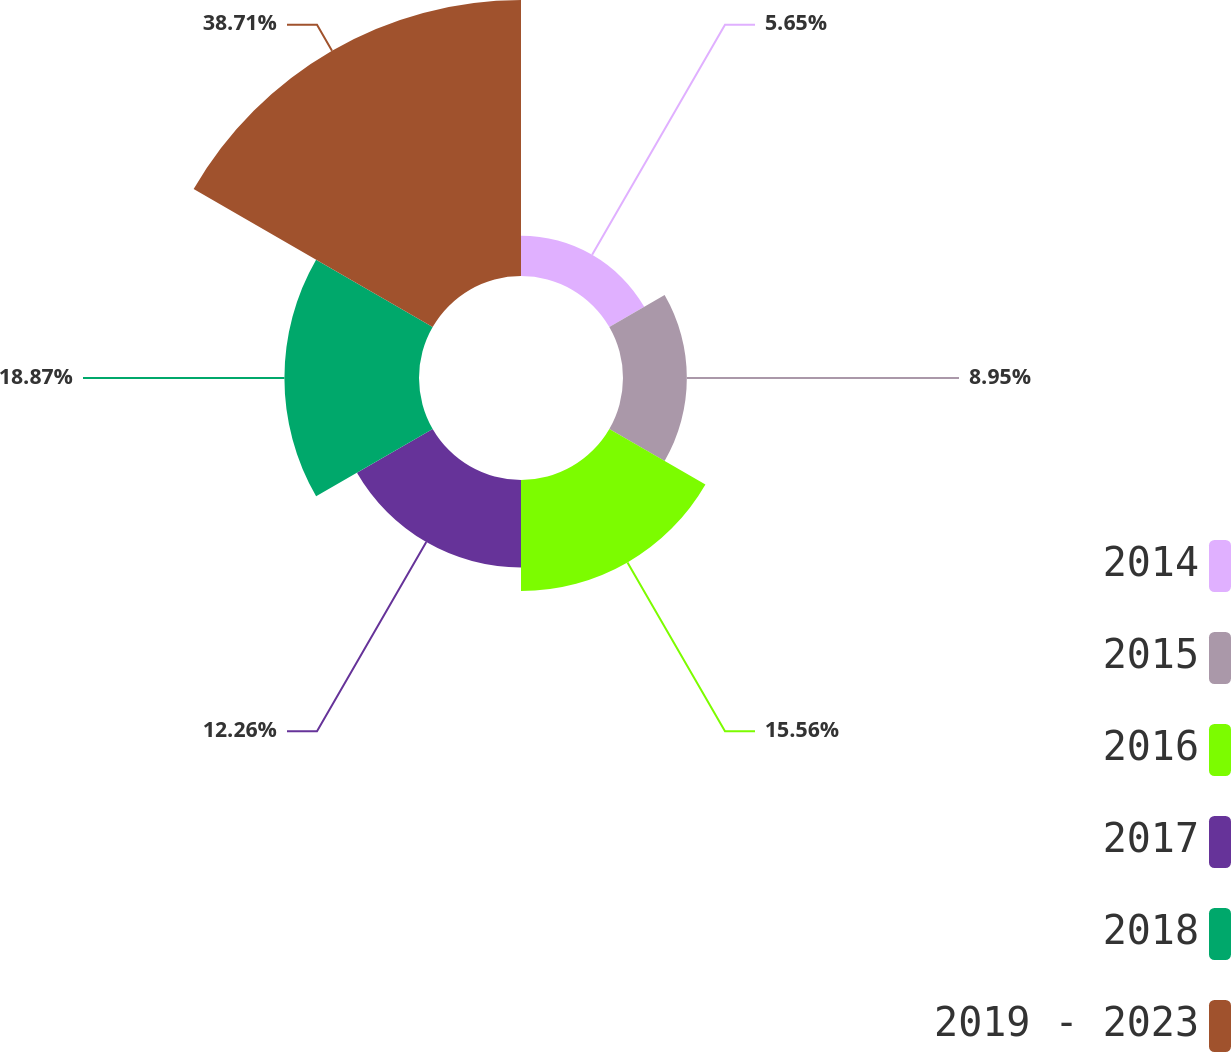Convert chart. <chart><loc_0><loc_0><loc_500><loc_500><pie_chart><fcel>2014<fcel>2015<fcel>2016<fcel>2017<fcel>2018<fcel>2019 - 2023<nl><fcel>5.65%<fcel>8.95%<fcel>15.56%<fcel>12.26%<fcel>18.87%<fcel>38.7%<nl></chart> 